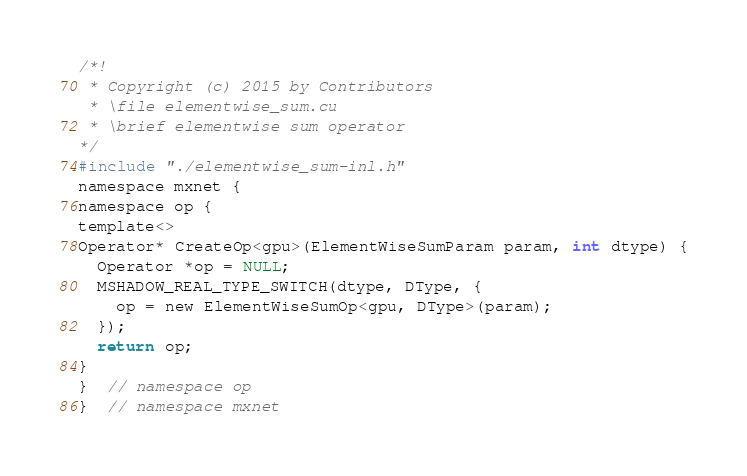Convert code to text. <code><loc_0><loc_0><loc_500><loc_500><_Cuda_>/*!
 * Copyright (c) 2015 by Contributors
 * \file elementwise_sum.cu
 * \brief elementwise sum operator
*/
#include "./elementwise_sum-inl.h"
namespace mxnet {
namespace op {
template<>
Operator* CreateOp<gpu>(ElementWiseSumParam param, int dtype) {
  Operator *op = NULL;
  MSHADOW_REAL_TYPE_SWITCH(dtype, DType, {
    op = new ElementWiseSumOp<gpu, DType>(param);
  });
  return op;
}
}  // namespace op
}  // namespace mxnet
</code> 